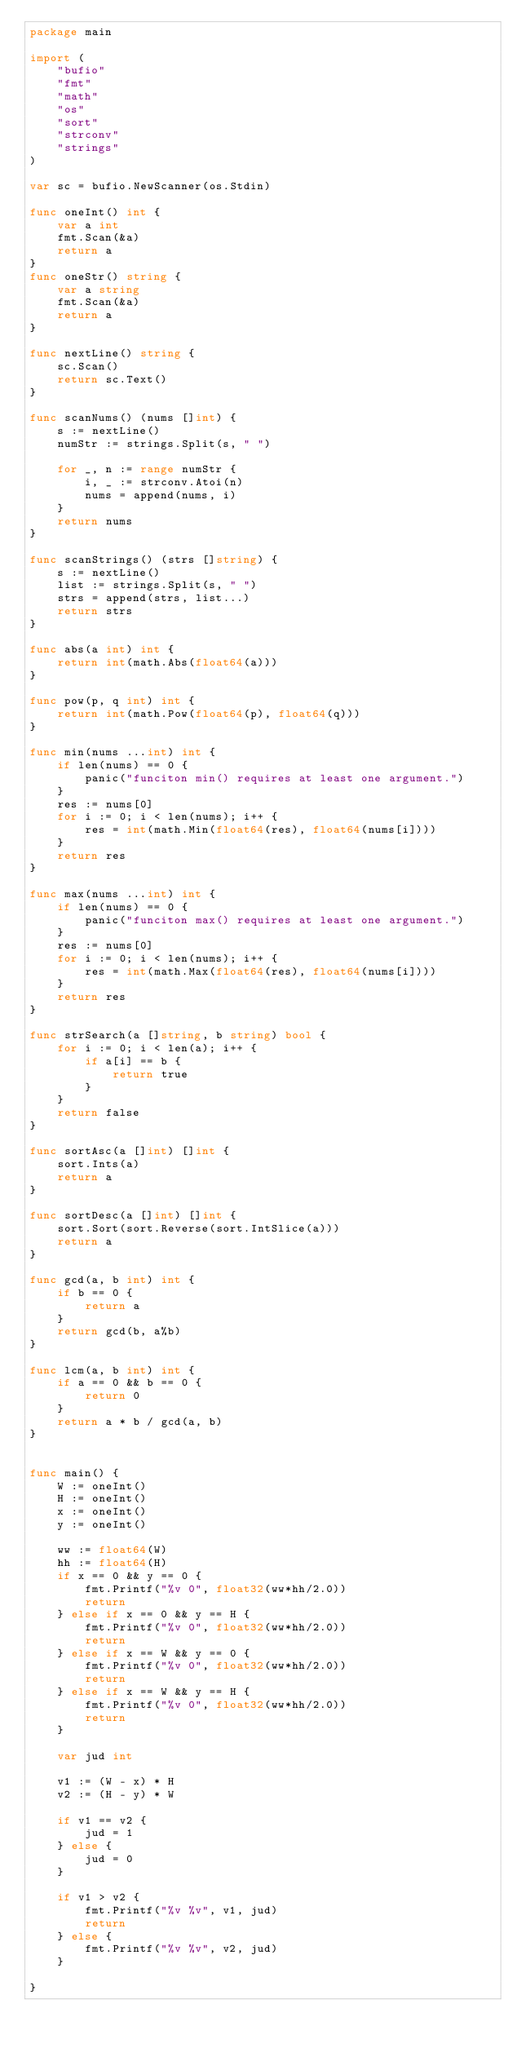Convert code to text. <code><loc_0><loc_0><loc_500><loc_500><_Go_>package main

import (
	"bufio"
	"fmt"
	"math"
	"os"
	"sort"
	"strconv"
	"strings"
)

var sc = bufio.NewScanner(os.Stdin)

func oneInt() int {
	var a int
	fmt.Scan(&a)
	return a
}
func oneStr() string {
	var a string
	fmt.Scan(&a)
	return a
}

func nextLine() string {
	sc.Scan()
	return sc.Text()
}

func scanNums() (nums []int) {
	s := nextLine()
	numStr := strings.Split(s, " ")

	for _, n := range numStr {
		i, _ := strconv.Atoi(n)
		nums = append(nums, i)
	}
	return nums
}

func scanStrings() (strs []string) {
	s := nextLine()
	list := strings.Split(s, " ")
	strs = append(strs, list...)
	return strs
}

func abs(a int) int {
	return int(math.Abs(float64(a)))
}

func pow(p, q int) int {
	return int(math.Pow(float64(p), float64(q)))
}

func min(nums ...int) int {
	if len(nums) == 0 {
		panic("funciton min() requires at least one argument.")
	}
	res := nums[0]
	for i := 0; i < len(nums); i++ {
		res = int(math.Min(float64(res), float64(nums[i])))
	}
	return res
}

func max(nums ...int) int {
	if len(nums) == 0 {
		panic("funciton max() requires at least one argument.")
	}
	res := nums[0]
	for i := 0; i < len(nums); i++ {
		res = int(math.Max(float64(res), float64(nums[i])))
	}
	return res
}

func strSearch(a []string, b string) bool {
	for i := 0; i < len(a); i++ {
		if a[i] == b {
			return true
		}
	}
	return false
}

func sortAsc(a []int) []int {
	sort.Ints(a)
	return a
}

func sortDesc(a []int) []int {
	sort.Sort(sort.Reverse(sort.IntSlice(a)))
	return a
}

func gcd(a, b int) int {
	if b == 0 {
		return a
	}
	return gcd(b, a%b)
}

func lcm(a, b int) int {
	if a == 0 && b == 0 {
		return 0
	}
	return a * b / gcd(a, b)
}


func main() {
	W := oneInt()
	H := oneInt()
	x := oneInt()
	y := oneInt()

	ww := float64(W)
	hh := float64(H)
	if x == 0 && y == 0 {
		fmt.Printf("%v 0", float32(ww*hh/2.0))
		return
	} else if x == 0 && y == H {
		fmt.Printf("%v 0", float32(ww*hh/2.0))
		return
	} else if x == W && y == 0 {
		fmt.Printf("%v 0", float32(ww*hh/2.0))
		return
	} else if x == W && y == H {
		fmt.Printf("%v 0", float32(ww*hh/2.0))
		return
	}

	var jud int

	v1 := (W - x) * H
	v2 := (H - y) * W

	if v1 == v2 {
		jud = 1
	} else {
		jud = 0
	}

	if v1 > v2 {
		fmt.Printf("%v %v", v1, jud)
		return
	} else {
		fmt.Printf("%v %v", v2, jud)
	}

}
</code> 